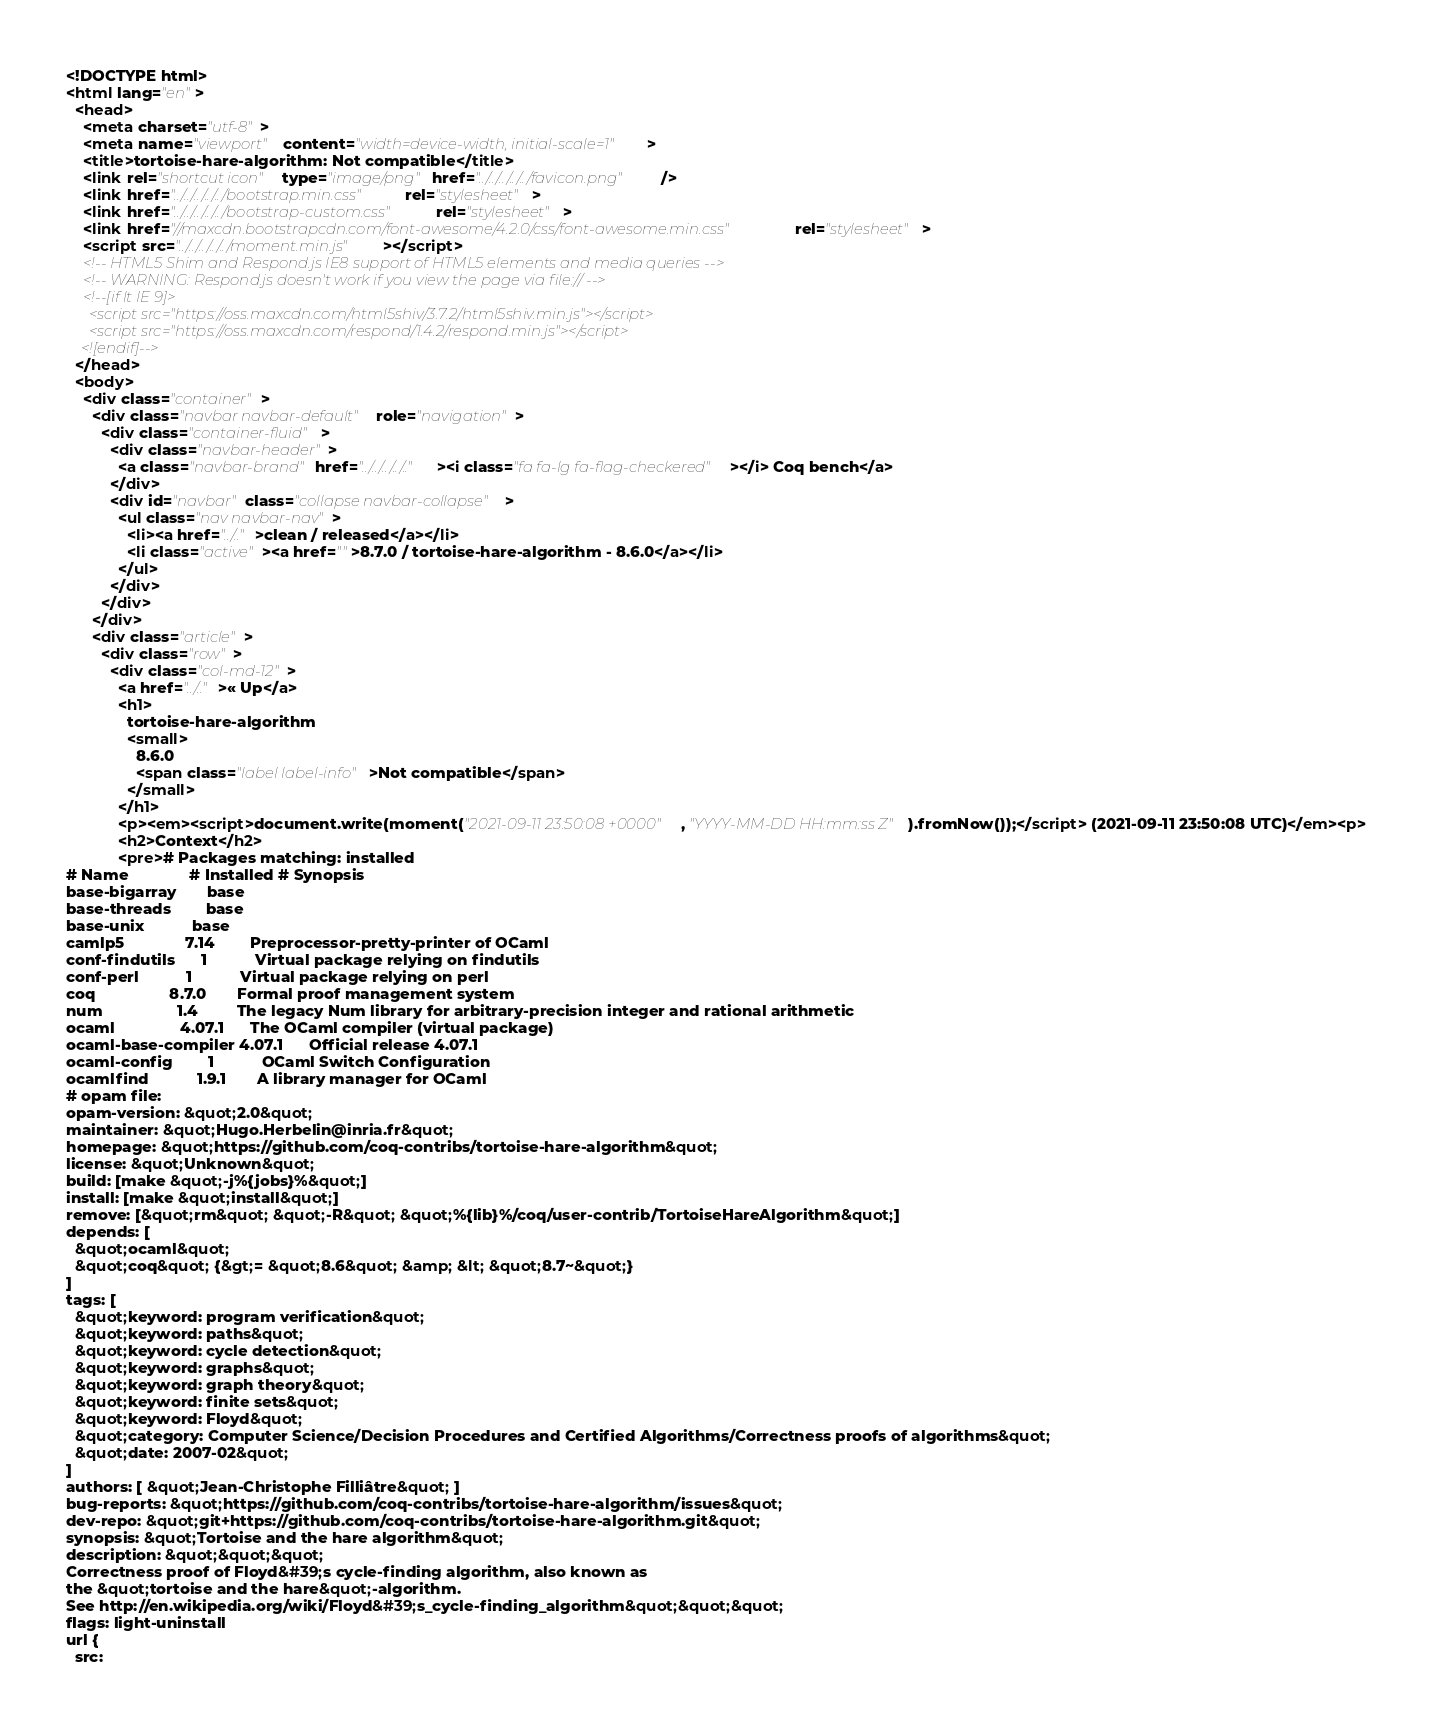<code> <loc_0><loc_0><loc_500><loc_500><_HTML_><!DOCTYPE html>
<html lang="en">
  <head>
    <meta charset="utf-8">
    <meta name="viewport" content="width=device-width, initial-scale=1">
    <title>tortoise-hare-algorithm: Not compatible</title>
    <link rel="shortcut icon" type="image/png" href="../../../../../favicon.png" />
    <link href="../../../../../bootstrap.min.css" rel="stylesheet">
    <link href="../../../../../bootstrap-custom.css" rel="stylesheet">
    <link href="//maxcdn.bootstrapcdn.com/font-awesome/4.2.0/css/font-awesome.min.css" rel="stylesheet">
    <script src="../../../../../moment.min.js"></script>
    <!-- HTML5 Shim and Respond.js IE8 support of HTML5 elements and media queries -->
    <!-- WARNING: Respond.js doesn't work if you view the page via file:// -->
    <!--[if lt IE 9]>
      <script src="https://oss.maxcdn.com/html5shiv/3.7.2/html5shiv.min.js"></script>
      <script src="https://oss.maxcdn.com/respond/1.4.2/respond.min.js"></script>
    <![endif]-->
  </head>
  <body>
    <div class="container">
      <div class="navbar navbar-default" role="navigation">
        <div class="container-fluid">
          <div class="navbar-header">
            <a class="navbar-brand" href="../../../../.."><i class="fa fa-lg fa-flag-checkered"></i> Coq bench</a>
          </div>
          <div id="navbar" class="collapse navbar-collapse">
            <ul class="nav navbar-nav">
              <li><a href="../..">clean / released</a></li>
              <li class="active"><a href="">8.7.0 / tortoise-hare-algorithm - 8.6.0</a></li>
            </ul>
          </div>
        </div>
      </div>
      <div class="article">
        <div class="row">
          <div class="col-md-12">
            <a href="../..">« Up</a>
            <h1>
              tortoise-hare-algorithm
              <small>
                8.6.0
                <span class="label label-info">Not compatible</span>
              </small>
            </h1>
            <p><em><script>document.write(moment("2021-09-11 23:50:08 +0000", "YYYY-MM-DD HH:mm:ss Z").fromNow());</script> (2021-09-11 23:50:08 UTC)</em><p>
            <h2>Context</h2>
            <pre># Packages matching: installed
# Name              # Installed # Synopsis
base-bigarray       base
base-threads        base
base-unix           base
camlp5              7.14        Preprocessor-pretty-printer of OCaml
conf-findutils      1           Virtual package relying on findutils
conf-perl           1           Virtual package relying on perl
coq                 8.7.0       Formal proof management system
num                 1.4         The legacy Num library for arbitrary-precision integer and rational arithmetic
ocaml               4.07.1      The OCaml compiler (virtual package)
ocaml-base-compiler 4.07.1      Official release 4.07.1
ocaml-config        1           OCaml Switch Configuration
ocamlfind           1.9.1       A library manager for OCaml
# opam file:
opam-version: &quot;2.0&quot;
maintainer: &quot;Hugo.Herbelin@inria.fr&quot;
homepage: &quot;https://github.com/coq-contribs/tortoise-hare-algorithm&quot;
license: &quot;Unknown&quot;
build: [make &quot;-j%{jobs}%&quot;]
install: [make &quot;install&quot;]
remove: [&quot;rm&quot; &quot;-R&quot; &quot;%{lib}%/coq/user-contrib/TortoiseHareAlgorithm&quot;]
depends: [
  &quot;ocaml&quot;
  &quot;coq&quot; {&gt;= &quot;8.6&quot; &amp; &lt; &quot;8.7~&quot;}
]
tags: [
  &quot;keyword: program verification&quot;
  &quot;keyword: paths&quot;
  &quot;keyword: cycle detection&quot;
  &quot;keyword: graphs&quot;
  &quot;keyword: graph theory&quot;
  &quot;keyword: finite sets&quot;
  &quot;keyword: Floyd&quot;
  &quot;category: Computer Science/Decision Procedures and Certified Algorithms/Correctness proofs of algorithms&quot;
  &quot;date: 2007-02&quot;
]
authors: [ &quot;Jean-Christophe Filliâtre&quot; ]
bug-reports: &quot;https://github.com/coq-contribs/tortoise-hare-algorithm/issues&quot;
dev-repo: &quot;git+https://github.com/coq-contribs/tortoise-hare-algorithm.git&quot;
synopsis: &quot;Tortoise and the hare algorithm&quot;
description: &quot;&quot;&quot;
Correctness proof of Floyd&#39;s cycle-finding algorithm, also known as
the &quot;tortoise and the hare&quot;-algorithm.
See http://en.wikipedia.org/wiki/Floyd&#39;s_cycle-finding_algorithm&quot;&quot;&quot;
flags: light-uninstall
url {
  src:</code> 